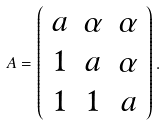Convert formula to latex. <formula><loc_0><loc_0><loc_500><loc_500>A = \left ( \begin{array} { c c c } a & \alpha & \alpha \\ 1 & a & \alpha \\ 1 & 1 & a \end{array} \right ) .</formula> 